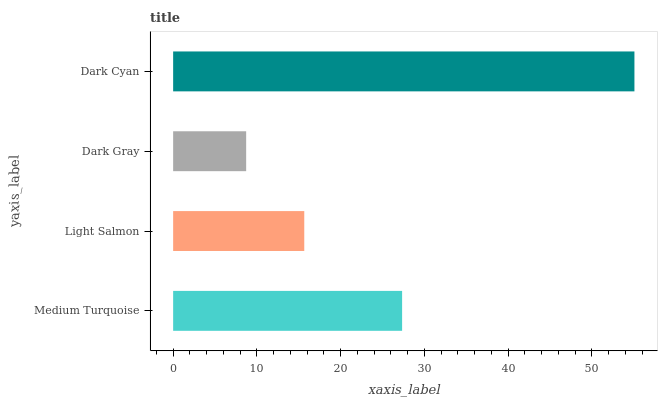Is Dark Gray the minimum?
Answer yes or no. Yes. Is Dark Cyan the maximum?
Answer yes or no. Yes. Is Light Salmon the minimum?
Answer yes or no. No. Is Light Salmon the maximum?
Answer yes or no. No. Is Medium Turquoise greater than Light Salmon?
Answer yes or no. Yes. Is Light Salmon less than Medium Turquoise?
Answer yes or no. Yes. Is Light Salmon greater than Medium Turquoise?
Answer yes or no. No. Is Medium Turquoise less than Light Salmon?
Answer yes or no. No. Is Medium Turquoise the high median?
Answer yes or no. Yes. Is Light Salmon the low median?
Answer yes or no. Yes. Is Dark Cyan the high median?
Answer yes or no. No. Is Dark Gray the low median?
Answer yes or no. No. 